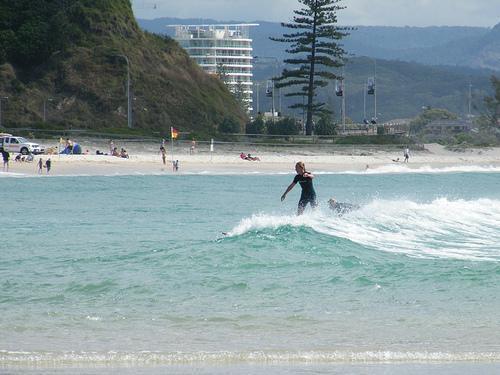How many boats are in the water?
Give a very brief answer. 0. 